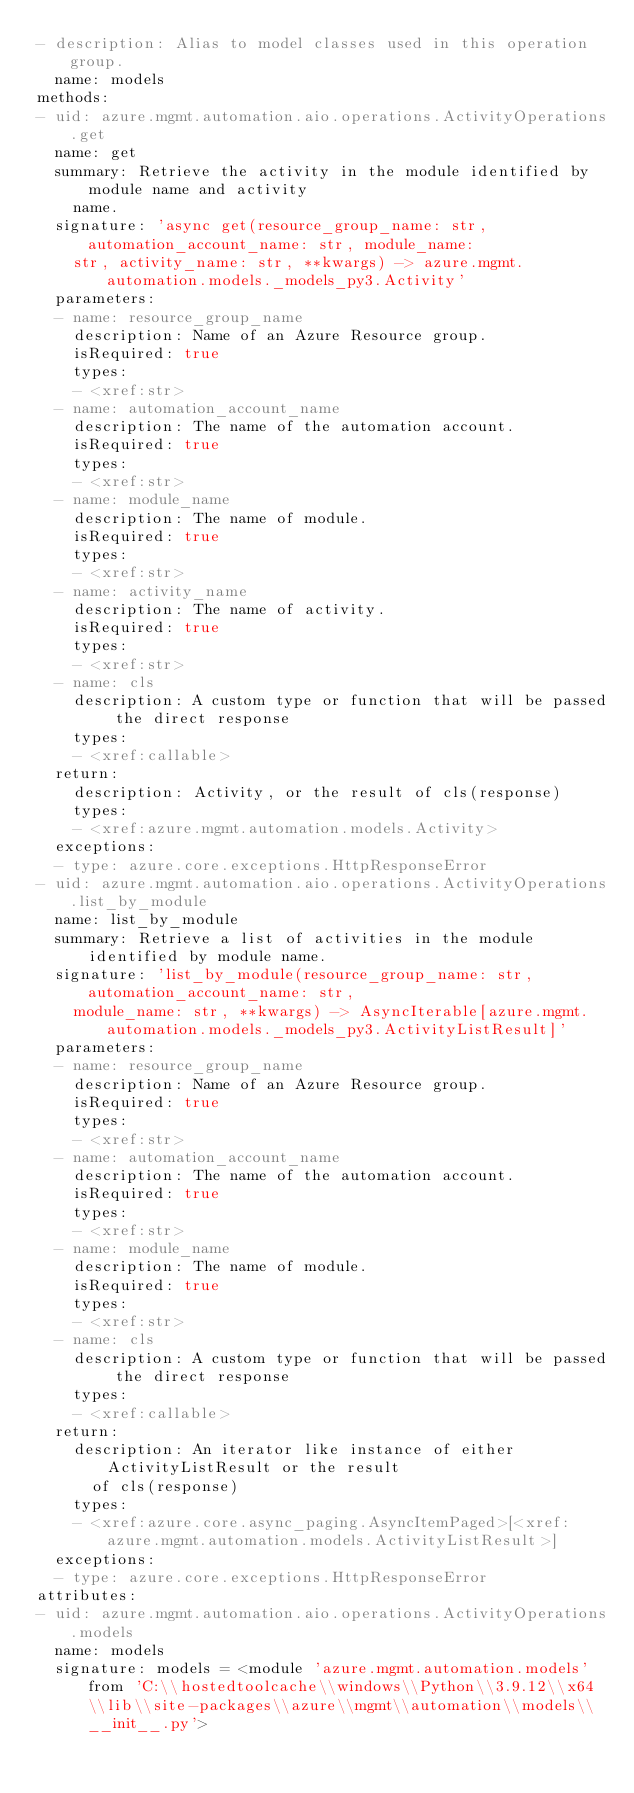Convert code to text. <code><loc_0><loc_0><loc_500><loc_500><_YAML_>- description: Alias to model classes used in this operation group.
  name: models
methods:
- uid: azure.mgmt.automation.aio.operations.ActivityOperations.get
  name: get
  summary: Retrieve the activity in the module identified by module name and activity
    name.
  signature: 'async get(resource_group_name: str, automation_account_name: str, module_name:
    str, activity_name: str, **kwargs) -> azure.mgmt.automation.models._models_py3.Activity'
  parameters:
  - name: resource_group_name
    description: Name of an Azure Resource group.
    isRequired: true
    types:
    - <xref:str>
  - name: automation_account_name
    description: The name of the automation account.
    isRequired: true
    types:
    - <xref:str>
  - name: module_name
    description: The name of module.
    isRequired: true
    types:
    - <xref:str>
  - name: activity_name
    description: The name of activity.
    isRequired: true
    types:
    - <xref:str>
  - name: cls
    description: A custom type or function that will be passed the direct response
    types:
    - <xref:callable>
  return:
    description: Activity, or the result of cls(response)
    types:
    - <xref:azure.mgmt.automation.models.Activity>
  exceptions:
  - type: azure.core.exceptions.HttpResponseError
- uid: azure.mgmt.automation.aio.operations.ActivityOperations.list_by_module
  name: list_by_module
  summary: Retrieve a list of activities in the module identified by module name.
  signature: 'list_by_module(resource_group_name: str, automation_account_name: str,
    module_name: str, **kwargs) -> AsyncIterable[azure.mgmt.automation.models._models_py3.ActivityListResult]'
  parameters:
  - name: resource_group_name
    description: Name of an Azure Resource group.
    isRequired: true
    types:
    - <xref:str>
  - name: automation_account_name
    description: The name of the automation account.
    isRequired: true
    types:
    - <xref:str>
  - name: module_name
    description: The name of module.
    isRequired: true
    types:
    - <xref:str>
  - name: cls
    description: A custom type or function that will be passed the direct response
    types:
    - <xref:callable>
  return:
    description: An iterator like instance of either ActivityListResult or the result
      of cls(response)
    types:
    - <xref:azure.core.async_paging.AsyncItemPaged>[<xref:azure.mgmt.automation.models.ActivityListResult>]
  exceptions:
  - type: azure.core.exceptions.HttpResponseError
attributes:
- uid: azure.mgmt.automation.aio.operations.ActivityOperations.models
  name: models
  signature: models = <module 'azure.mgmt.automation.models' from 'C:\\hostedtoolcache\\windows\\Python\\3.9.12\\x64\\lib\\site-packages\\azure\\mgmt\\automation\\models\\__init__.py'>
</code> 